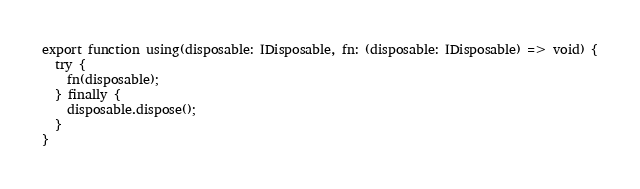<code> <loc_0><loc_0><loc_500><loc_500><_TypeScript_>export function using(disposable: IDisposable, fn: (disposable: IDisposable) => void) {
  try {
    fn(disposable);
  } finally {
    disposable.dispose();
  }
}</code> 